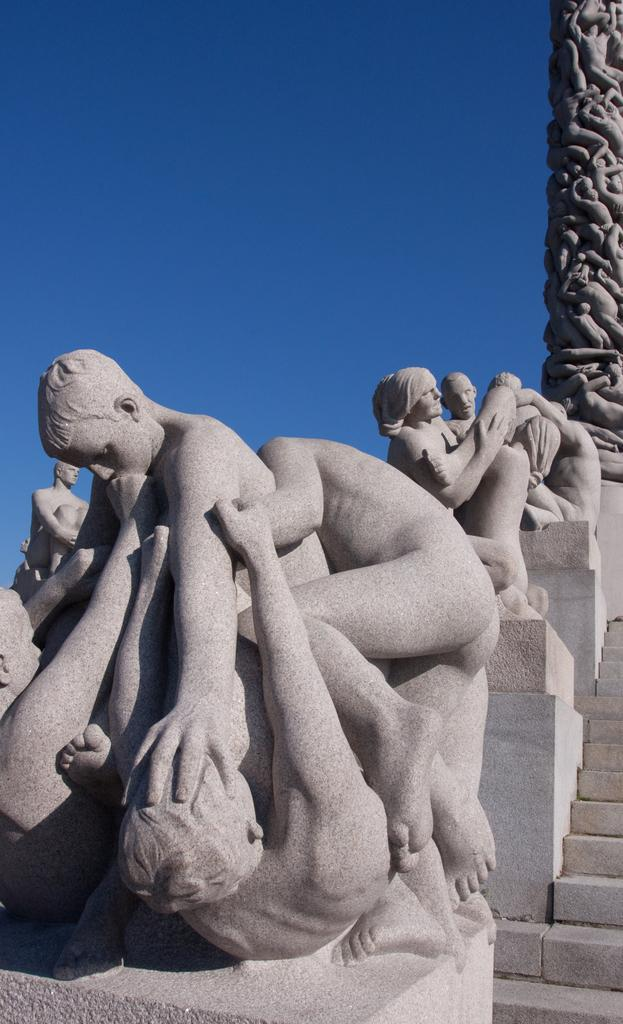What is the main subject of the image? The main subject of the image is a sculpture of people. What architectural feature can be seen in the image? There are stairs in the image in the image. What other structural element is present in the image? There is a pillar in the image. What is visible in the background of the image? The sky is visible in the image. What type of pan is being used to cook food in the image? There is no pan or cooking activity present in the image; it features a sculpture of people, stairs, a pillar, and the sky. 